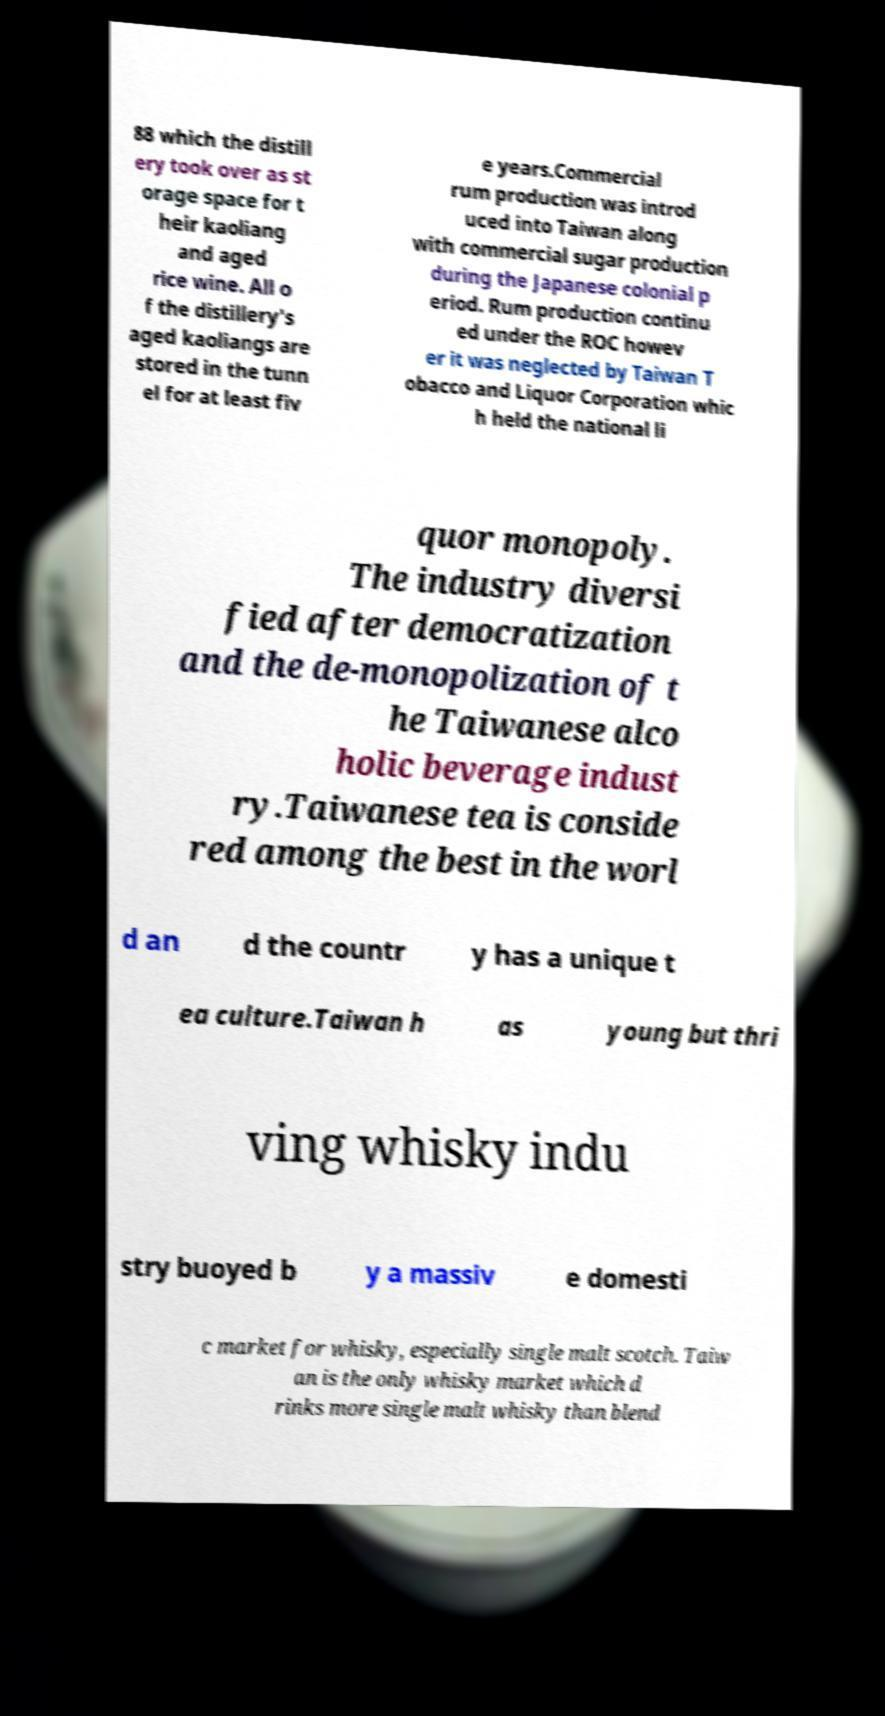Could you assist in decoding the text presented in this image and type it out clearly? 88 which the distill ery took over as st orage space for t heir kaoliang and aged rice wine. All o f the distillery's aged kaoliangs are stored in the tunn el for at least fiv e years.Commercial rum production was introd uced into Taiwan along with commercial sugar production during the Japanese colonial p eriod. Rum production continu ed under the ROC howev er it was neglected by Taiwan T obacco and Liquor Corporation whic h held the national li quor monopoly. The industry diversi fied after democratization and the de-monopolization of t he Taiwanese alco holic beverage indust ry.Taiwanese tea is conside red among the best in the worl d an d the countr y has a unique t ea culture.Taiwan h as young but thri ving whisky indu stry buoyed b y a massiv e domesti c market for whisky, especially single malt scotch. Taiw an is the only whisky market which d rinks more single malt whisky than blend 